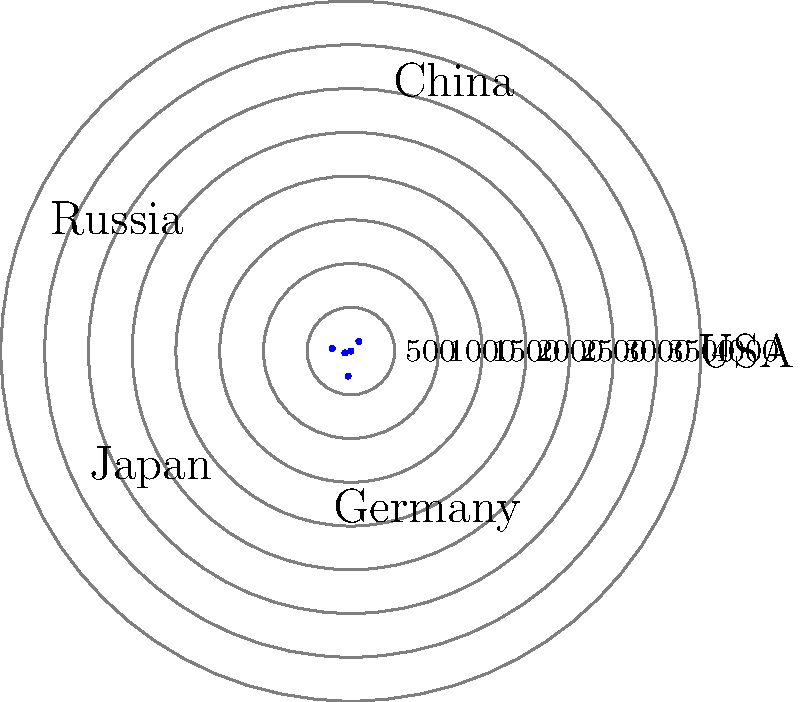Based on the polar chart representing energy consumption in various countries, which two nations have the most significant difference in their energy usage, and what geopolitical implications might this disparity have on global energy markets and international relations? To answer this question, we need to analyze the polar chart and follow these steps:

1. Identify the countries and their energy consumption:
   - USA: 3800 units
   - China: 2900 units
   - Russia: 2200 units
   - Japan: 1800 units
   - Germany: 1500 units

2. Calculate the differences between each pair of countries:
   - USA - China = 900 units
   - USA - Russia = 1600 units
   - USA - Japan = 2000 units
   - USA - Germany = 2300 units
   - China - Russia = 700 units
   - China - Japan = 1100 units
   - China - Germany = 1400 units
   - Russia - Japan = 400 units
   - Russia - Germany = 700 units
   - Japan - Germany = 300 units

3. Identify the largest difference:
   The largest difference is between the USA and Germany, with 2300 units.

4. Analyze the geopolitical implications:
   a) Energy dependency: Germany may be more dependent on energy imports, while the USA has greater energy independence.
   b) Economic impact: Higher energy consumption in the USA may indicate a larger industrial base or different energy efficiency standards.
   c) Environmental policies: The disparity might reflect different approaches to climate change and carbon emissions reduction.
   d) Technological advancements: The USA may have more energy-intensive industries or less efficient infrastructure compared to Germany.
   e) Energy diplomacy: The USA's higher consumption may give it more leverage in global energy markets and negotiations.
   f) Resource allocation: The disparity may influence how these countries approach international energy projects and investments.
   g) Security concerns: Energy security might be a more pressing issue for Germany, potentially affecting its foreign policy decisions.

These factors can significantly influence the dynamics of global energy markets and shape international relations between these countries and their allies.
Answer: USA and Germany; implications include energy dependency, economic impact, environmental policies, technological differences, energy diplomacy, resource allocation, and security concerns. 